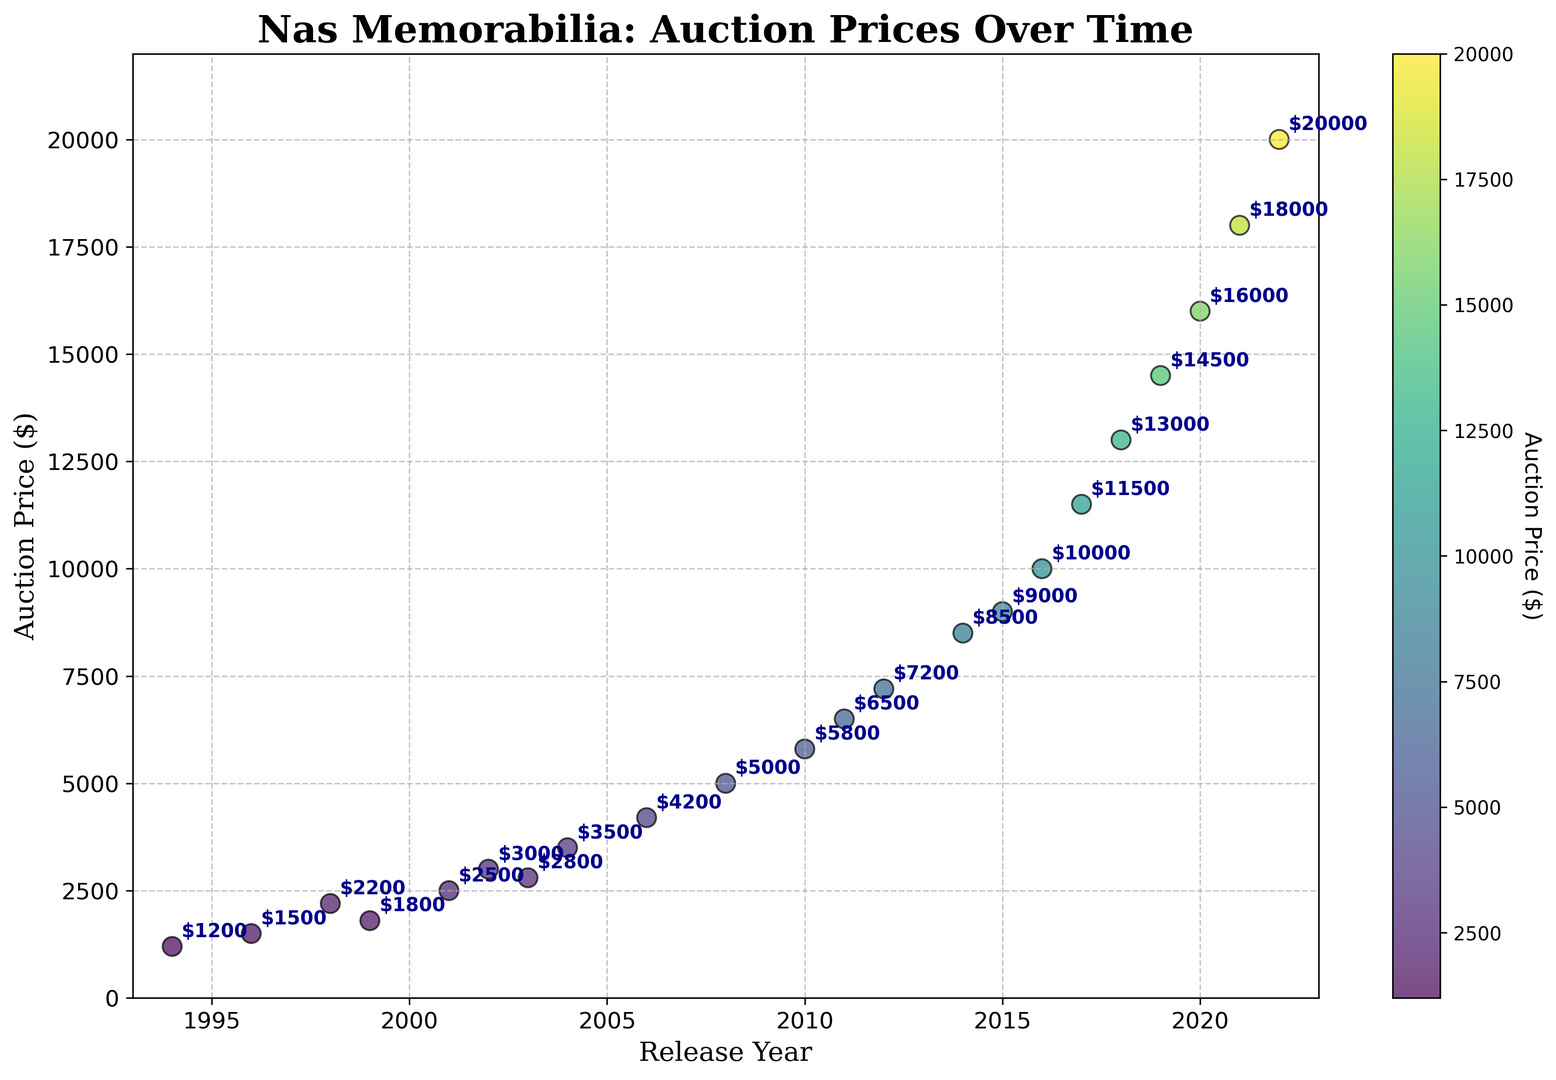Which year had the highest auction price for Nas memorabilia? By examining the scatter plot, identify the point on the graph with the highest vertical position. This point represents the highest auction price. The caption beside this point indicates the year.
Answer: 2022 What is the difference in auction prices between 1996 and 2002? Locate the points for the years 1996 and 2002 on the scatter plot. Notice the prices for these years are $1500 and $3000 respectively. Calculate the difference by subtracting the 1996 price from the 2002 price: $3000 - $1500.
Answer: $1500 How did the auction price trend between 1994 and 2004? Observe the points on the scatter plot from 1994 to 2004, noting the general direction in which the points move over this period. The points show prices increasing gradually over this decade.
Answer: Increasing What is the average auction price between 2010 and 2020? Identify the points corresponding to the years 2010 to 2020 on the scatter plot. The prices are $5800, $6500, $7200, $8500, $9000, $10000, $11500, $13000, $14500, $16000. Add these values and divide by the number of years (10) to find the average: ($5800 + $6500 + $7200 + $8500 + $9000 + $10000 + $11500 + $13000 + $14500 + $16000) / 10.
Answer: $10400 What is the trend in auction prices from 2001 to 2008? Look at the points corresponding to the years 2001 to 2008 on the scatter plot. The observed prices are $2500, $3000, $2800, $3500, $4200, $5000. The prices show a general increasing trend with a small dip in 2003.
Answer: Increasing What's the highest auction price below $2000, and which year was it? Locate all points on the scatter plot below the $2000 horizontal mark. Among these, the highest point is $1800, which corresponds to the year 1999.
Answer: 1999 Which year had the biggest single-year increase in auction price? Compare the auction prices year by year and find the largest increment between consecutive years. The largest increase is from $18000 in 2021 to $20000 in 2022, resulting in a $2000 increase.
Answer: 2022 What's the auction price trend from 2016 to 2018? Observe the points from 2016 to 2018 on the scatter plot: $10000, $11500, and $13000. Notice that each year's auction price is higher than the previous year's.
Answer: Increasing 